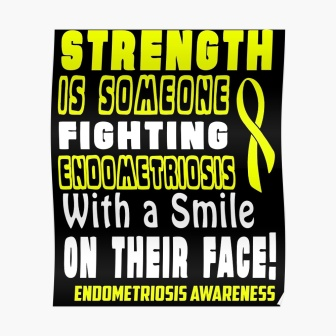Let’s imagine the poster is part of a larger campaign. What other elements could be included in the campaign? In addition to this poster, the campaign could include brochures with detailed information about endometriosis and its symptoms, resources for support groups, and ways to contribute to endometriosis research. Social media graphics, video testimonials from individuals with endometriosis, and awareness events like walks or webinars could be part of the campaign to reach a wider audience and foster a supportive community. 